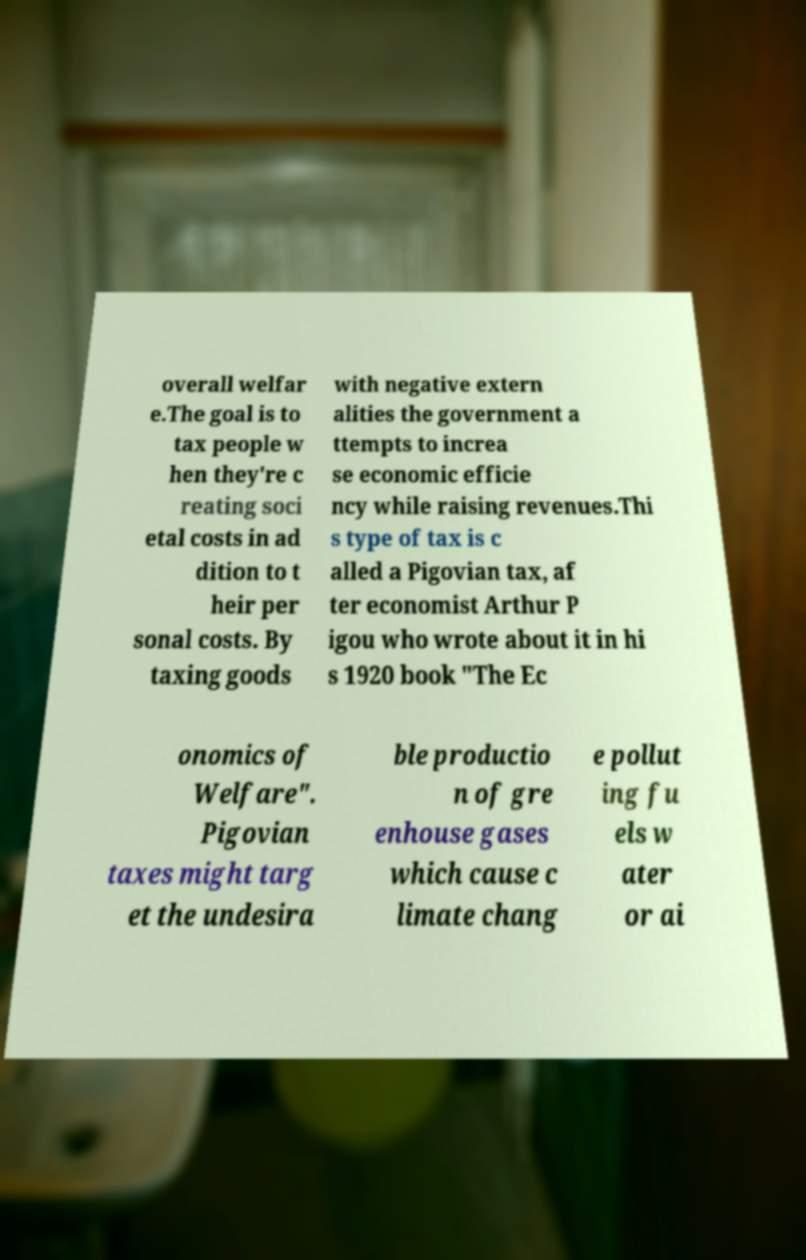Can you read and provide the text displayed in the image?This photo seems to have some interesting text. Can you extract and type it out for me? overall welfar e.The goal is to tax people w hen they're c reating soci etal costs in ad dition to t heir per sonal costs. By taxing goods with negative extern alities the government a ttempts to increa se economic efficie ncy while raising revenues.Thi s type of tax is c alled a Pigovian tax, af ter economist Arthur P igou who wrote about it in hi s 1920 book "The Ec onomics of Welfare". Pigovian taxes might targ et the undesira ble productio n of gre enhouse gases which cause c limate chang e pollut ing fu els w ater or ai 